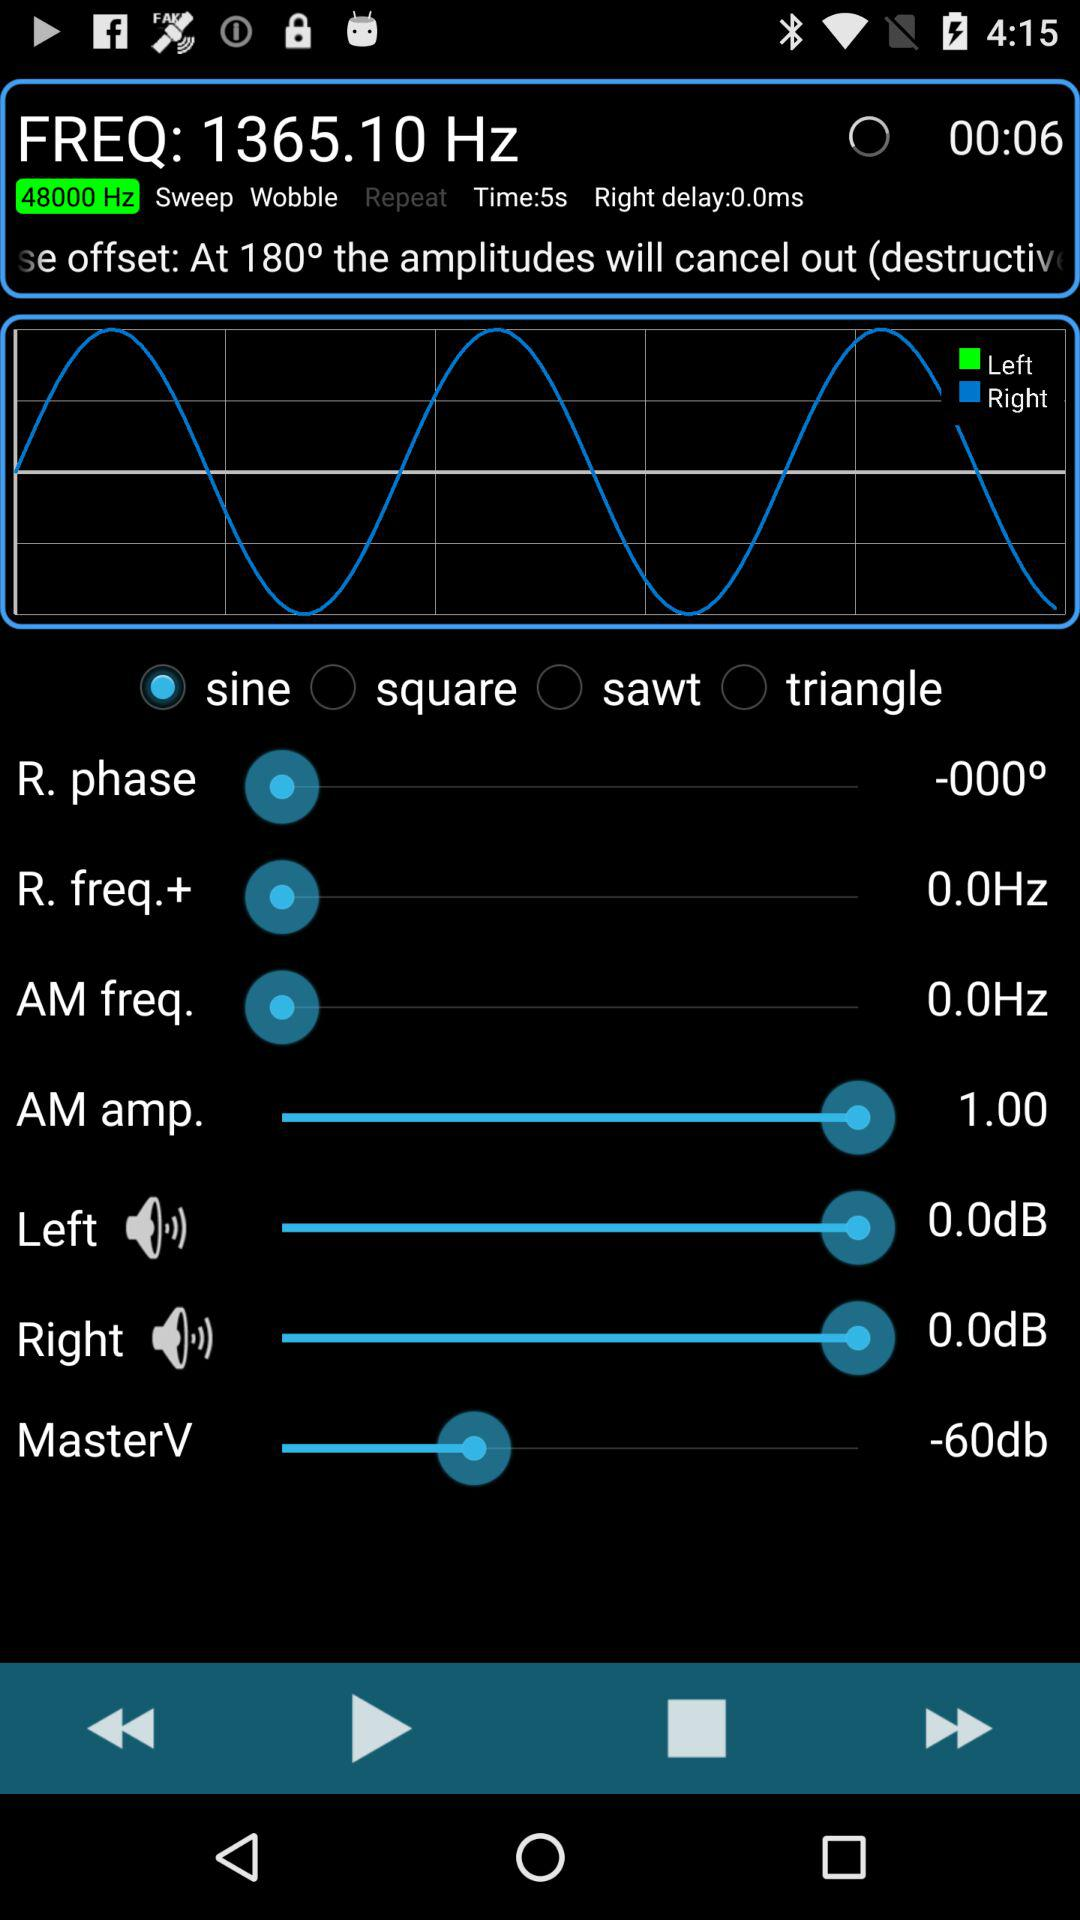Which is the selected option? The selected option is "sine". 